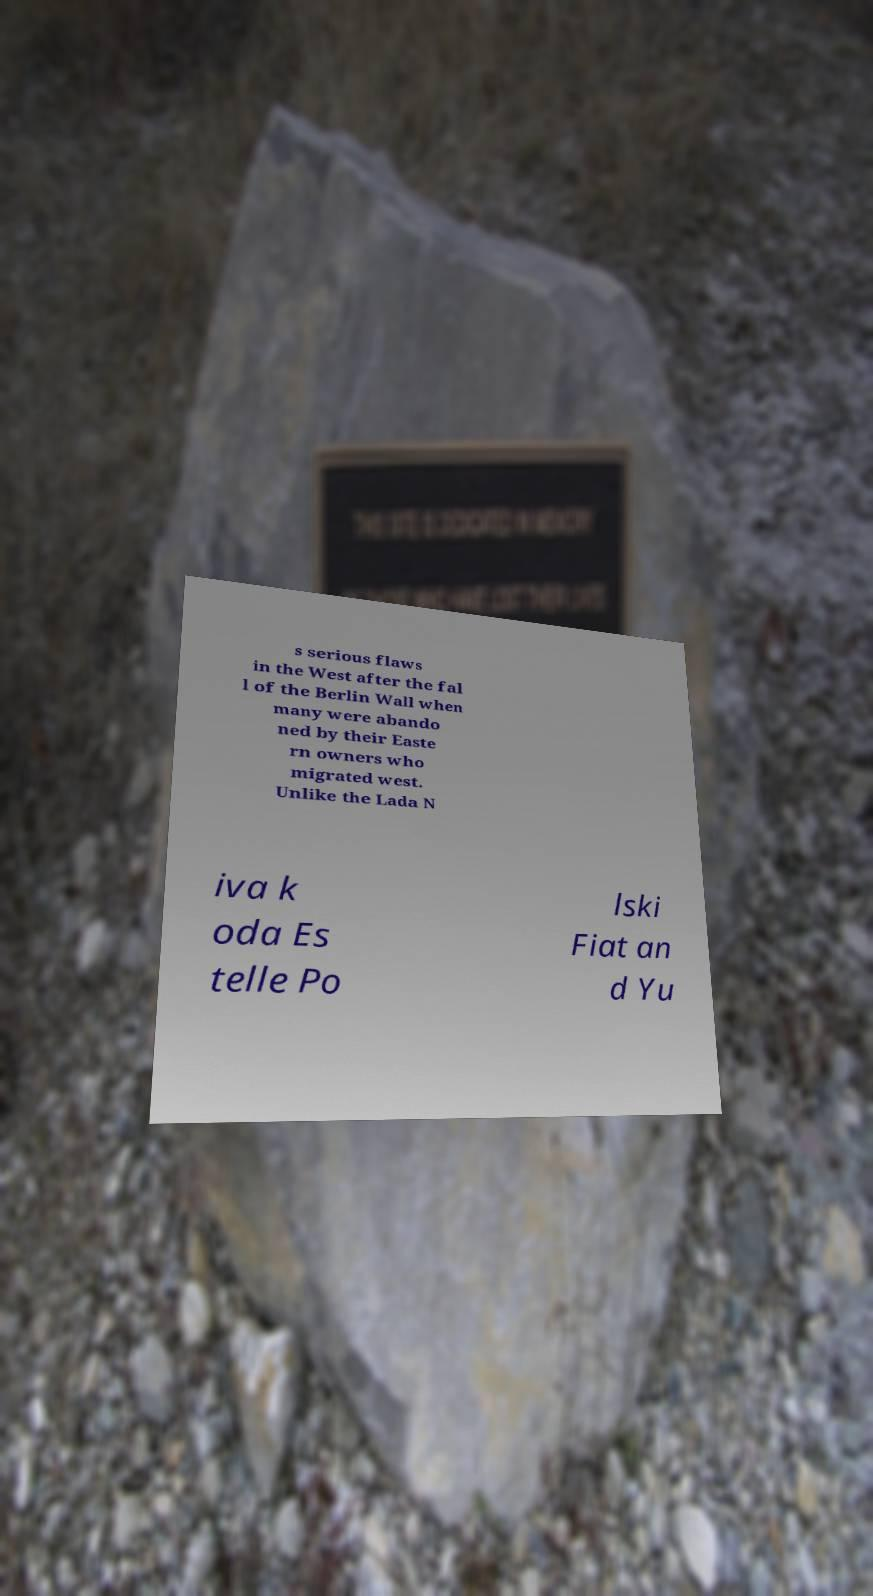Can you accurately transcribe the text from the provided image for me? s serious flaws in the West after the fal l of the Berlin Wall when many were abando ned by their Easte rn owners who migrated west. Unlike the Lada N iva k oda Es telle Po lski Fiat an d Yu 